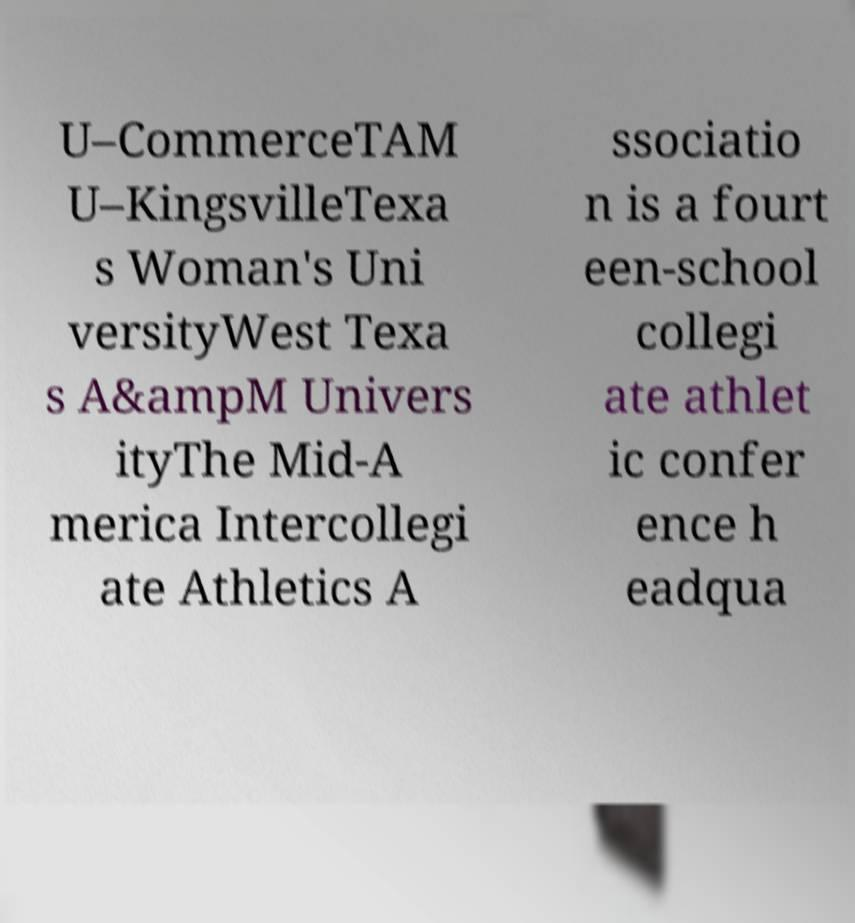Please read and relay the text visible in this image. What does it say? U–CommerceTAM U–KingsvilleTexa s Woman's Uni versityWest Texa s A&ampM Univers ityThe Mid-A merica Intercollegi ate Athletics A ssociatio n is a fourt een-school collegi ate athlet ic confer ence h eadqua 